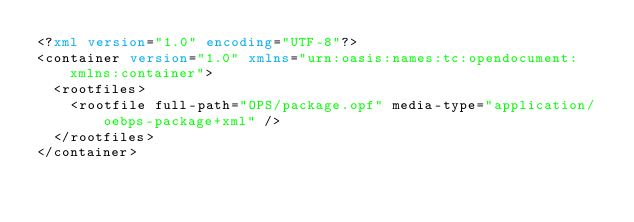Convert code to text. <code><loc_0><loc_0><loc_500><loc_500><_XML_><?xml version="1.0" encoding="UTF-8"?>
<container version="1.0" xmlns="urn:oasis:names:tc:opendocument:xmlns:container">
  <rootfiles>
    <rootfile full-path="OPS/package.opf" media-type="application/oebps-package+xml" />
  </rootfiles>
</container>
</code> 